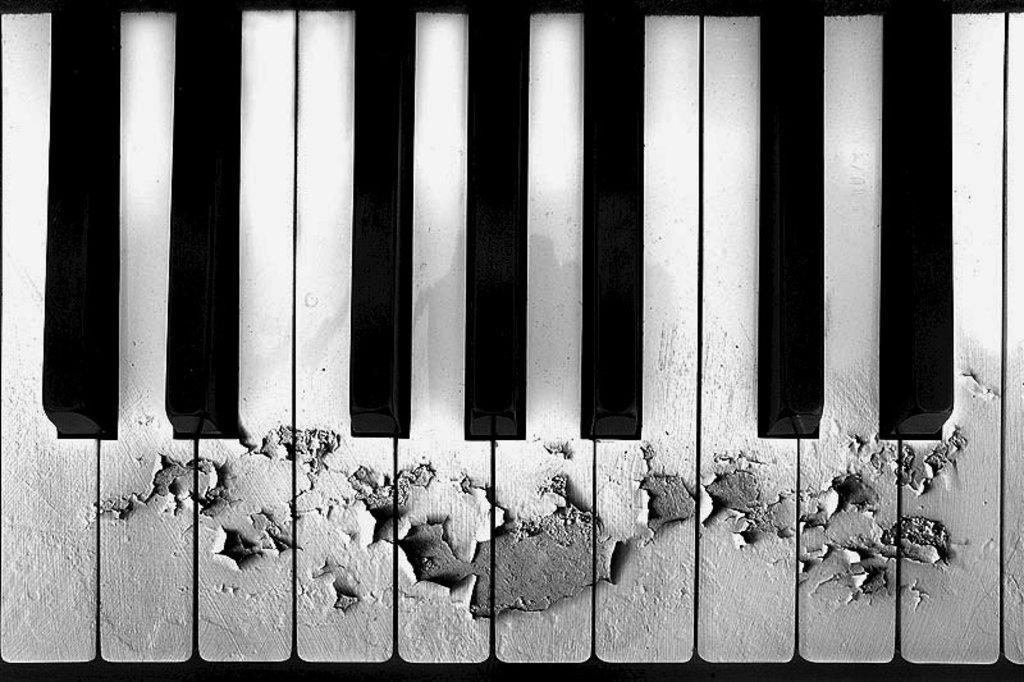Describe this image in one or two sentences. In this picture we can see a piano key board with black and white keys and this is made of wood were some part is removed. 